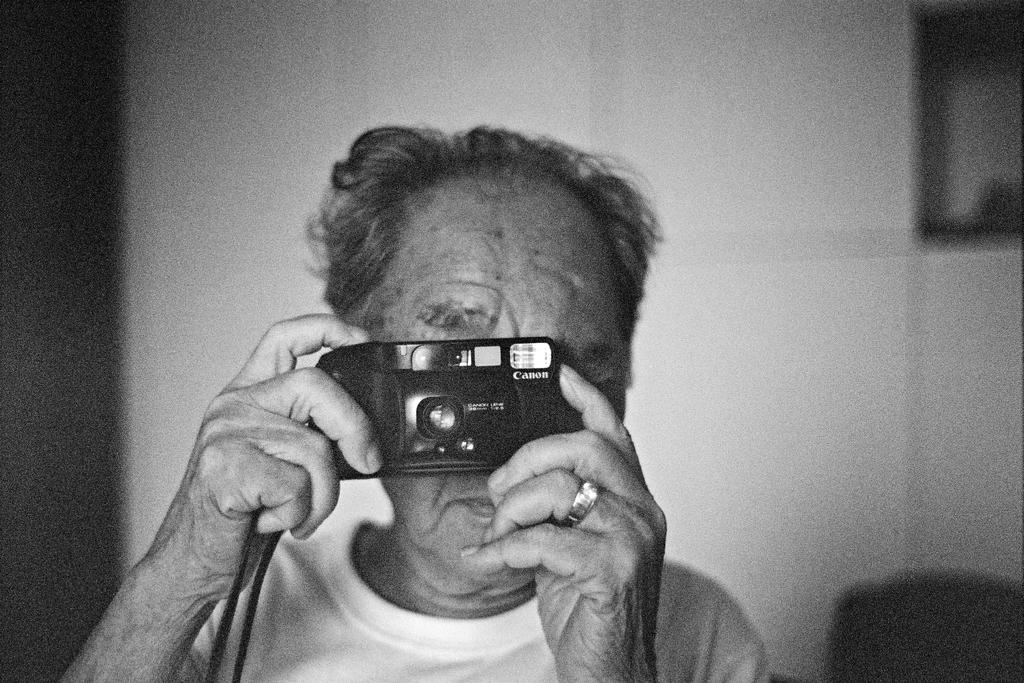Who is present in the image? There is a man in the image. What is the man holding in the image? The man is holding a camera. What can be seen in the background of the image? There is a wall in the background of the image. How many sheep are visible in the image? There are no sheep present in the image. What type of curtain is hanging from the wall in the image? There is no curtain visible in the image; only a wall is present in the background. 